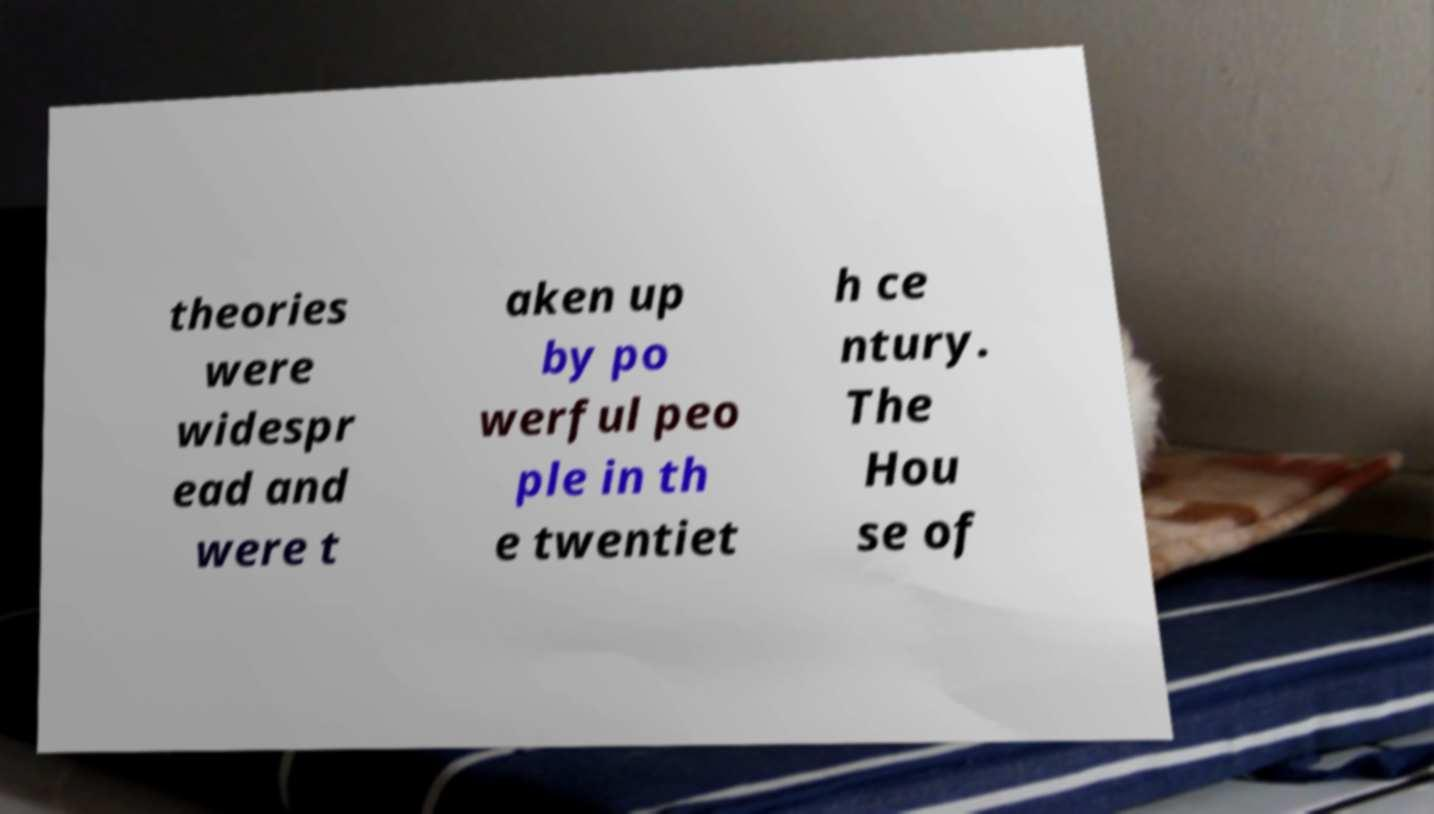Can you read and provide the text displayed in the image?This photo seems to have some interesting text. Can you extract and type it out for me? theories were widespr ead and were t aken up by po werful peo ple in th e twentiet h ce ntury. The Hou se of 